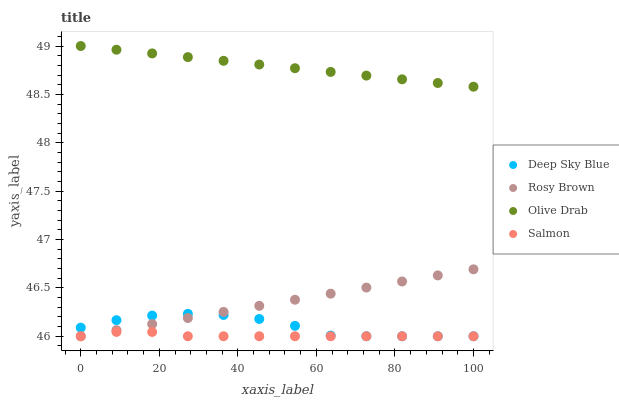Does Salmon have the minimum area under the curve?
Answer yes or no. Yes. Does Olive Drab have the maximum area under the curve?
Answer yes or no. Yes. Does Olive Drab have the minimum area under the curve?
Answer yes or no. No. Does Salmon have the maximum area under the curve?
Answer yes or no. No. Is Rosy Brown the smoothest?
Answer yes or no. Yes. Is Deep Sky Blue the roughest?
Answer yes or no. Yes. Is Salmon the smoothest?
Answer yes or no. No. Is Salmon the roughest?
Answer yes or no. No. Does Rosy Brown have the lowest value?
Answer yes or no. Yes. Does Olive Drab have the lowest value?
Answer yes or no. No. Does Olive Drab have the highest value?
Answer yes or no. Yes. Does Salmon have the highest value?
Answer yes or no. No. Is Salmon less than Olive Drab?
Answer yes or no. Yes. Is Olive Drab greater than Rosy Brown?
Answer yes or no. Yes. Does Salmon intersect Rosy Brown?
Answer yes or no. Yes. Is Salmon less than Rosy Brown?
Answer yes or no. No. Is Salmon greater than Rosy Brown?
Answer yes or no. No. Does Salmon intersect Olive Drab?
Answer yes or no. No. 